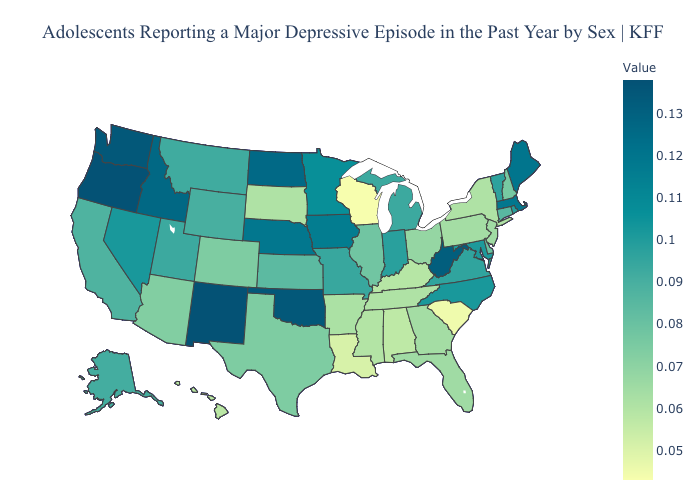Among the states that border Utah , which have the highest value?
Give a very brief answer. New Mexico. Does Ohio have a lower value than Virginia?
Keep it brief. Yes. Is the legend a continuous bar?
Be succinct. Yes. Which states have the lowest value in the USA?
Be succinct. Wisconsin. 